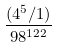<formula> <loc_0><loc_0><loc_500><loc_500>\frac { ( 4 ^ { 5 } / 1 ) } { 9 8 ^ { 1 2 2 } }</formula> 